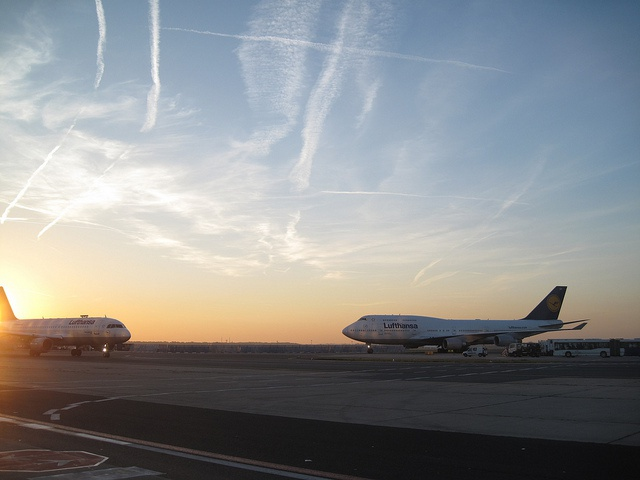Describe the objects in this image and their specific colors. I can see airplane in gray, black, and blue tones, airplane in gray, maroon, and orange tones, bus in gray, black, and darkblue tones, and truck in gray, black, and darkblue tones in this image. 